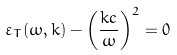<formula> <loc_0><loc_0><loc_500><loc_500>\varepsilon _ { T } ( \omega , { k } ) - { \left ( \frac { k c } { \omega } \right ) } ^ { 2 } = 0</formula> 